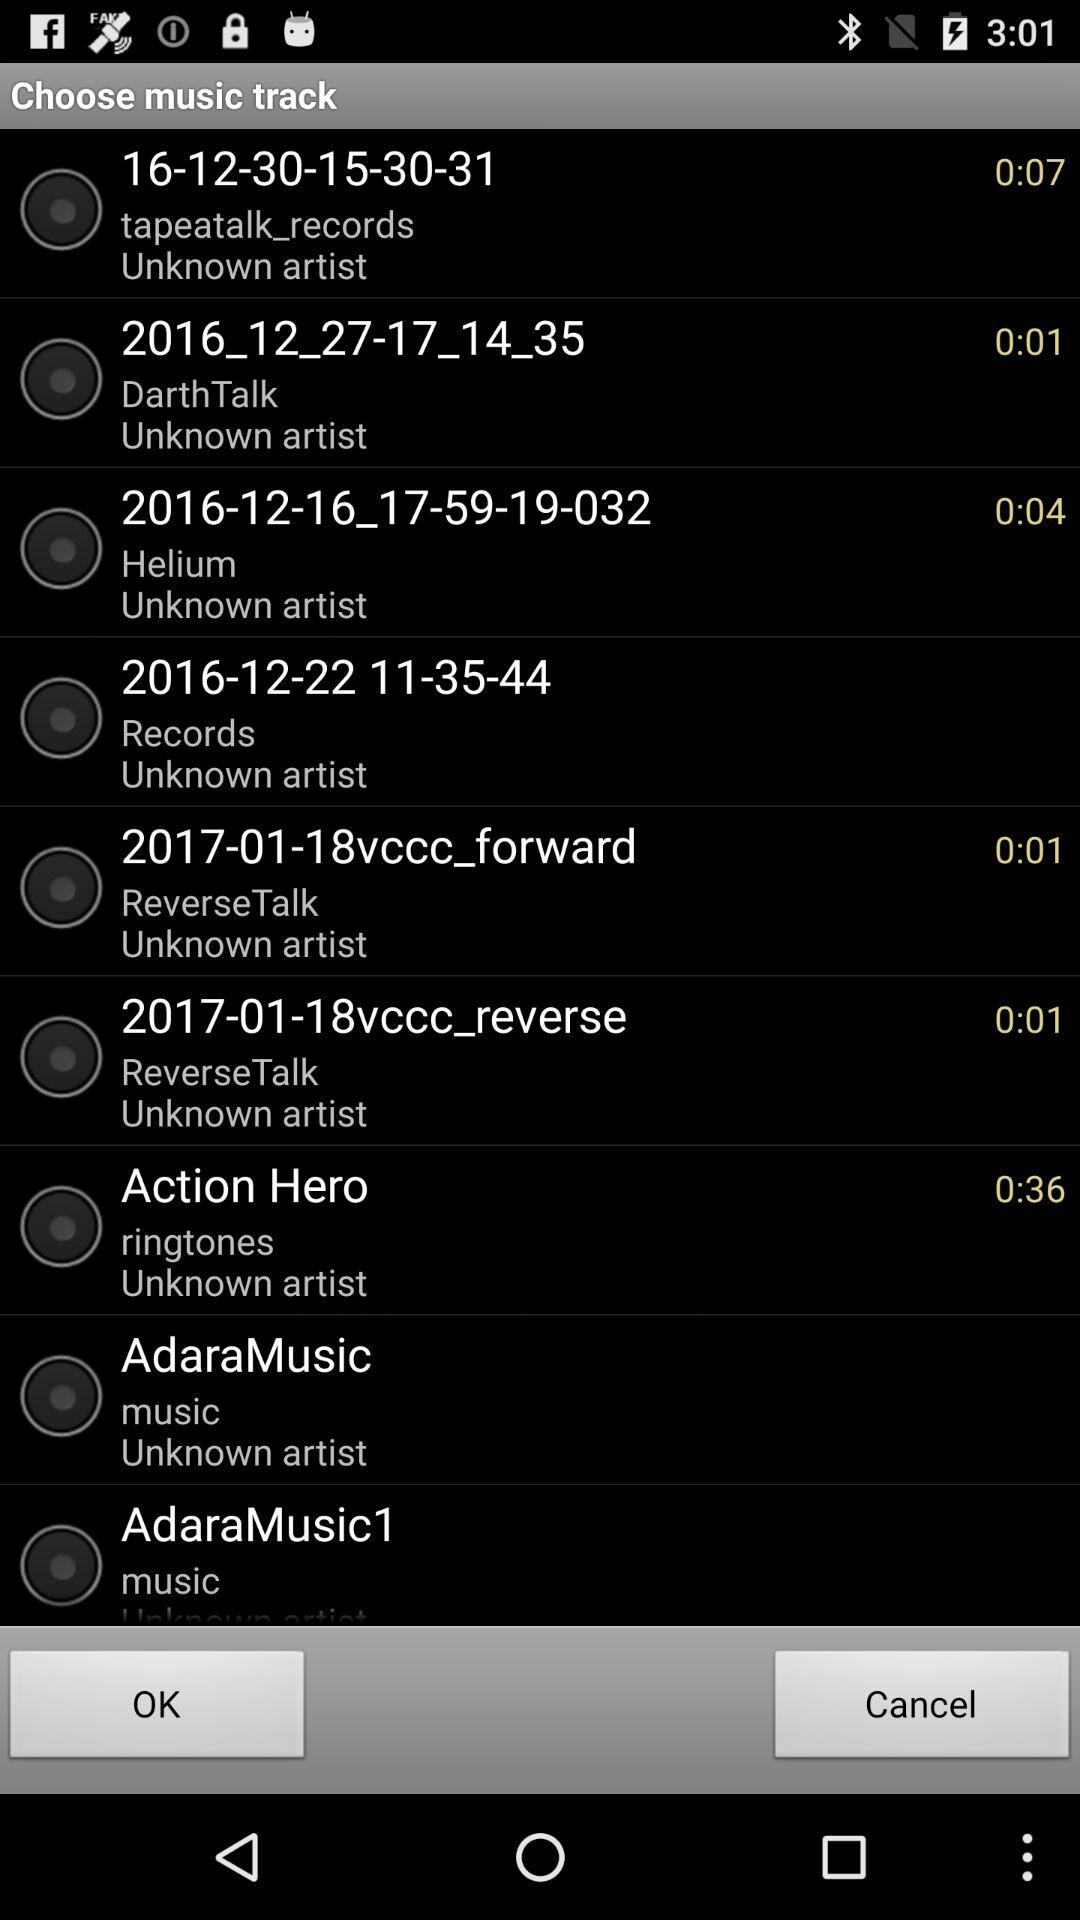What is the duration of the "Action Hero" ringtone? The duration of the "Action Hero" ringtone is 36 seconds. 